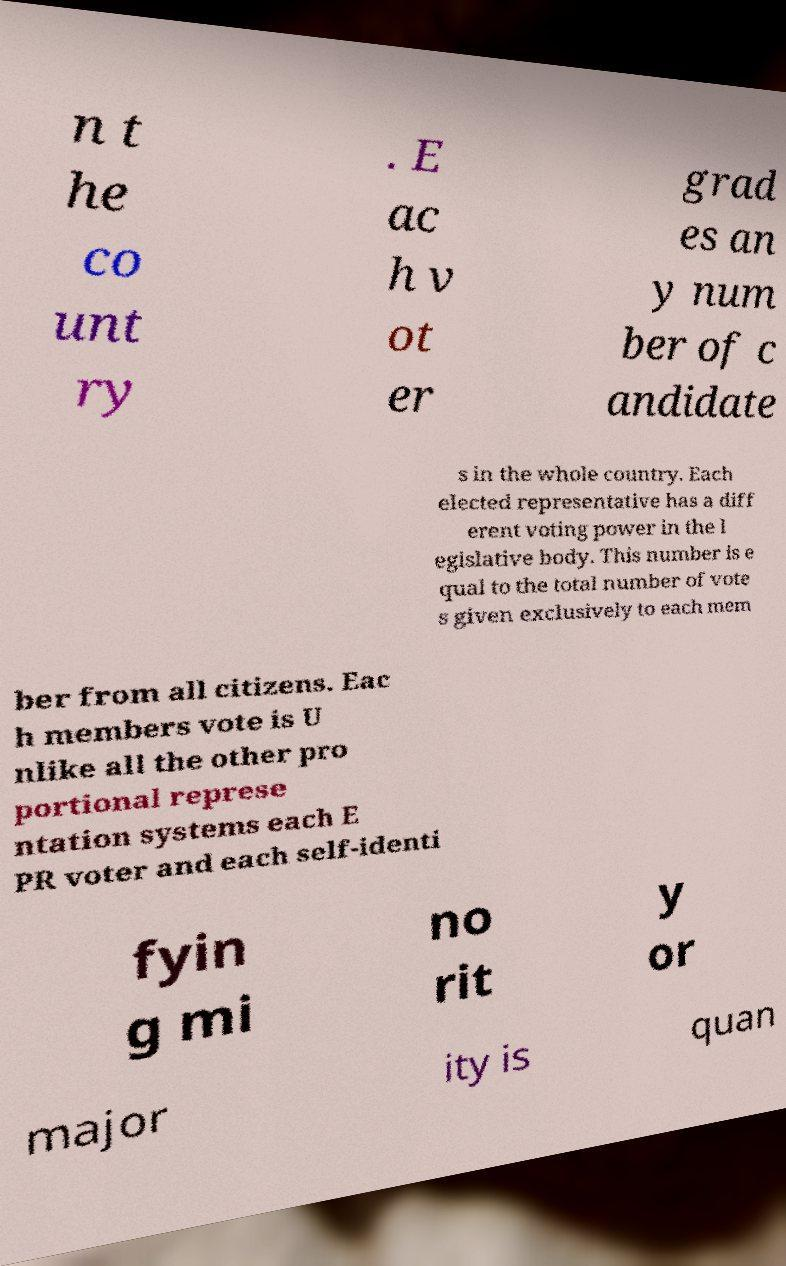Can you read and provide the text displayed in the image?This photo seems to have some interesting text. Can you extract and type it out for me? n t he co unt ry . E ac h v ot er grad es an y num ber of c andidate s in the whole country. Each elected representative has a diff erent voting power in the l egislative body. This number is e qual to the total number of vote s given exclusively to each mem ber from all citizens. Eac h members vote is U nlike all the other pro portional represe ntation systems each E PR voter and each self-identi fyin g mi no rit y or major ity is quan 